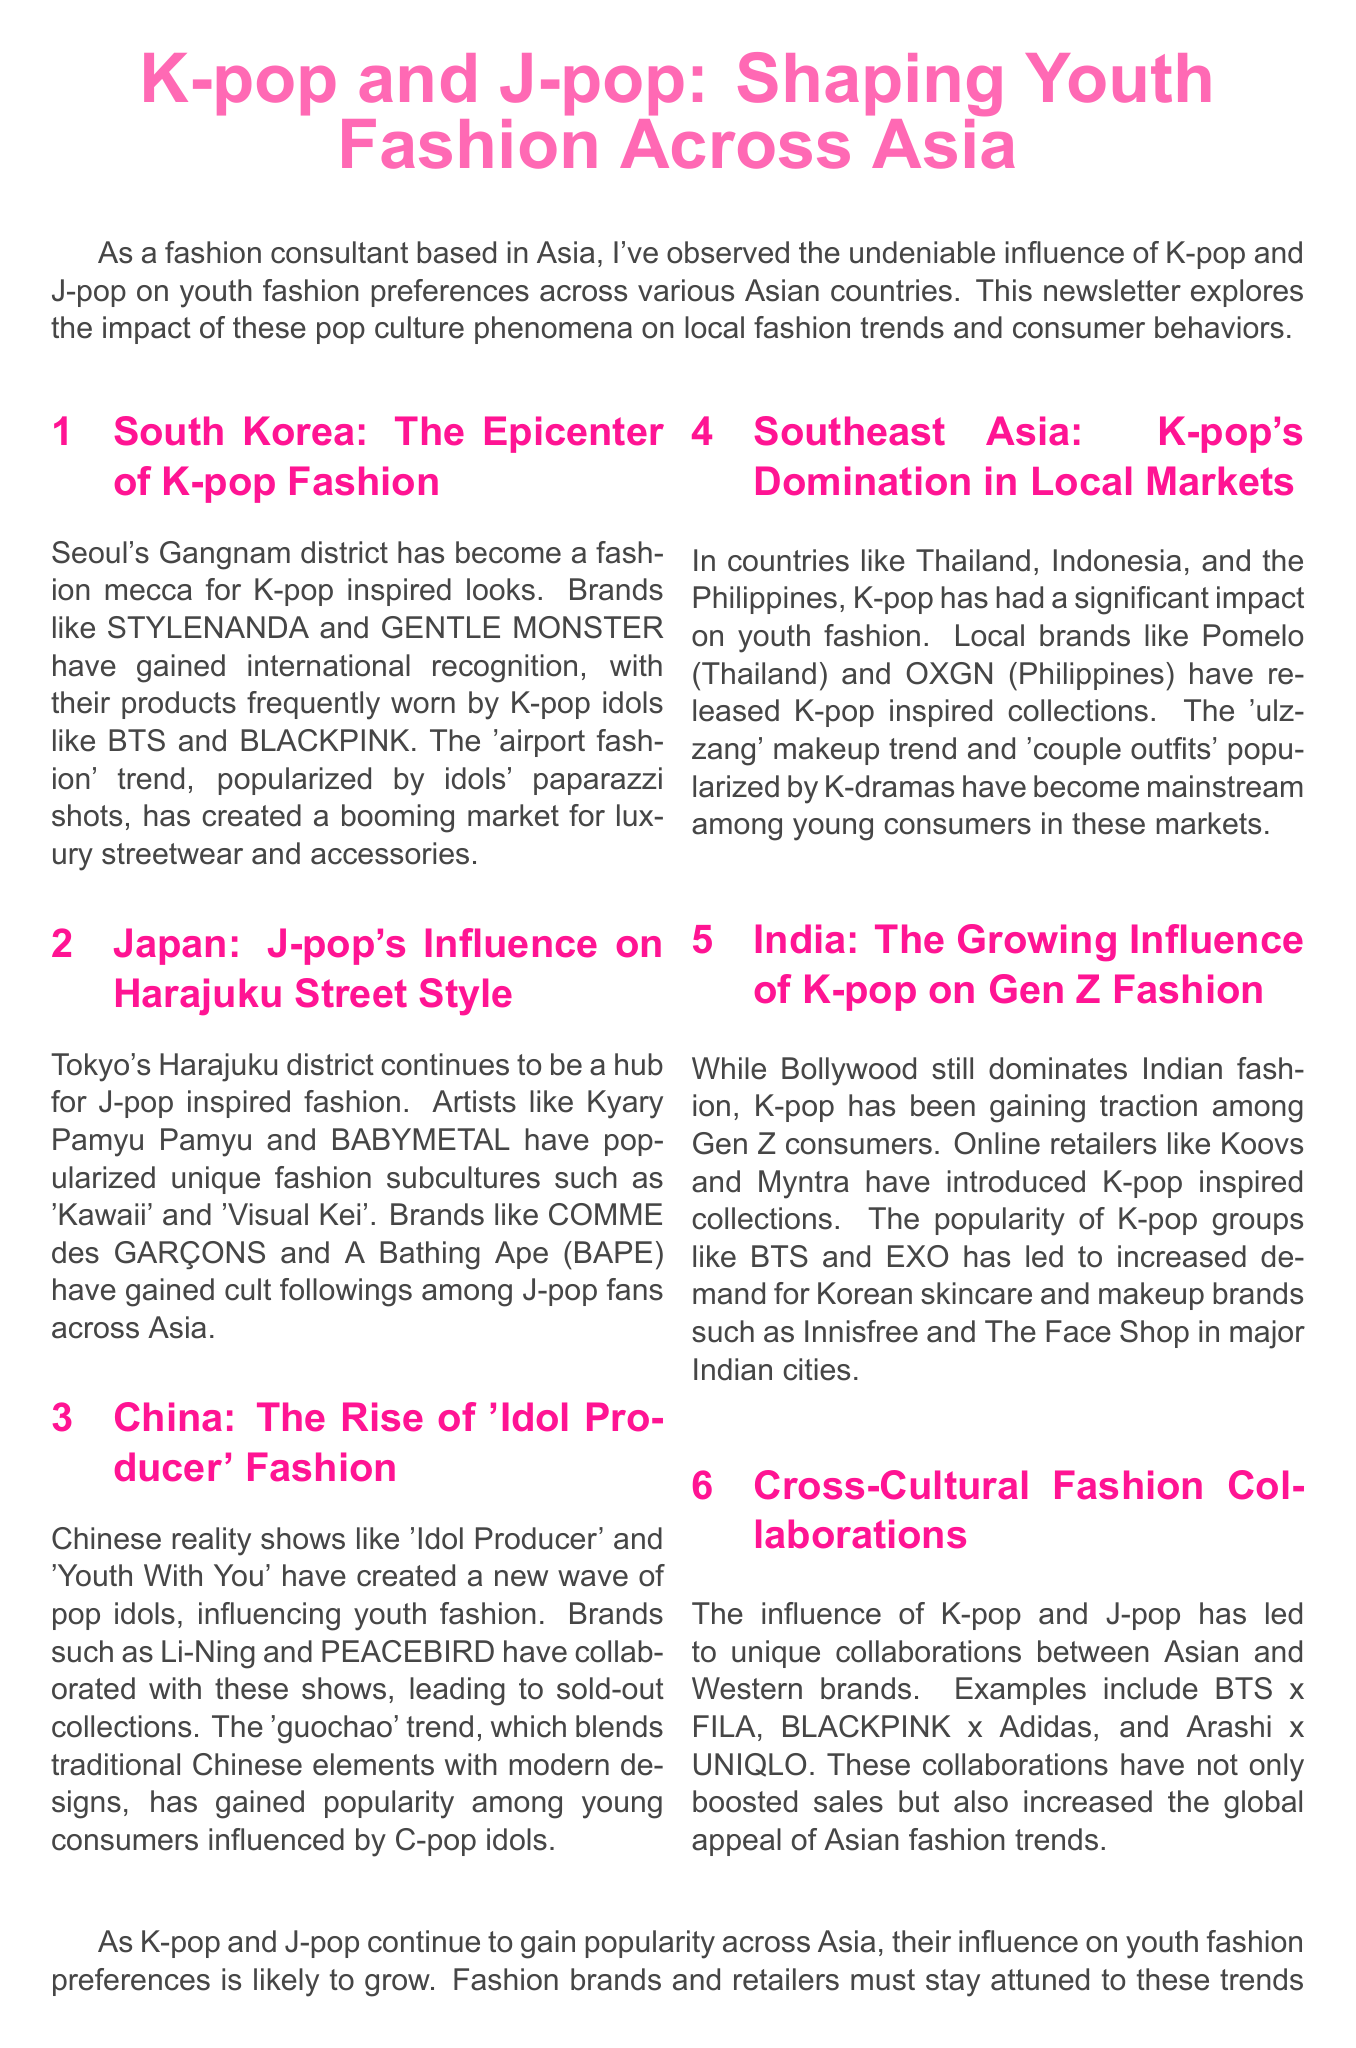What is the title of the newsletter? The title is explicitly stated at the beginning of the document, which is about K-pop and J-pop's impact on youth fashion.
Answer: K-pop and J-pop: Shaping Youth Fashion Across Asia Which district in South Korea is mentioned as a fashion mecca? The document specifies Gangnam district as a prominent location for K-pop inspired fashion.
Answer: Gangnam What is the term for fashion blending traditional Chinese elements with modern designs? The document refers to this trend as 'guochao', originating from the influence of C-pop idols.
Answer: guochao Which brands have collaborated with K-pop idols as mentioned in the document? The document lists specific collaborations, highlighting brands like FILA, Adidas, and UNIQLO in conjunction with popular idol groups.
Answer: BTS x FILA, BLACKPINK x Adidas, Arashi x UNIQLO What influence has K-pop had in India according to the newsletter? The document states that while Bollywood is dominant, K-pop influences Gen Z consumers in their fashion choices.
Answer: Gen Z Identify one brand associated with J-pop fashion trends mentioned in the document. The document highlights specific brands that are popular among J-pop fans, particularly noted for their unique fashion styles.
Answer: COMME des GARÇONS How many countries are discussed regarding K-pop and J-pop's influence on fashion? The newsletter explicitly outlines the influence in five different countries across Asia.
Answer: Five What type of fashion is popularized by K-drama according to the content? The document mentions specific fashion trends derived from K-dramas, particularly focusing on a particular type of outfit.
Answer: couple outfits 